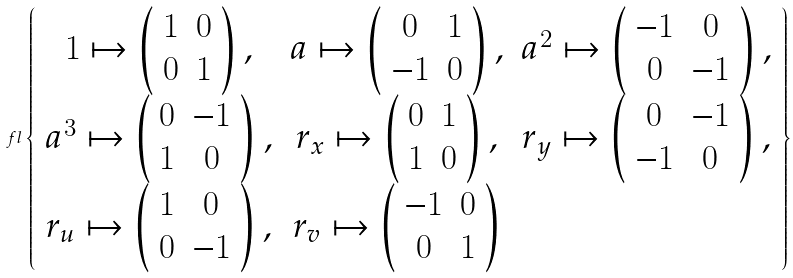<formula> <loc_0><loc_0><loc_500><loc_500>\ f l \left \{ \begin{array} { c c c c } 1 \mapsto \left ( \begin{array} { c c } 1 & 0 \\ 0 & 1 \end{array} \right ) , & a \mapsto \left ( \begin{array} { c c } 0 & 1 \\ - 1 & 0 \end{array} \right ) , & a ^ { 2 } \mapsto \left ( \begin{array} { c c } - 1 & 0 \\ 0 & - 1 \end{array} \right ) , \\ a ^ { 3 } \mapsto \left ( \begin{array} { c c } 0 & - 1 \\ 1 & 0 \end{array} \right ) , & r _ { x } \mapsto \left ( \begin{array} { c c } 0 & 1 \\ 1 & 0 \end{array} \right ) , & r _ { y } \mapsto \left ( \begin{array} { c c } 0 & - 1 \\ - 1 & 0 \end{array} \right ) , \\ r _ { u } \mapsto \left ( \begin{array} { c c } 1 & 0 \\ 0 & - 1 \end{array} \right ) , & r _ { v } \mapsto \left ( \begin{array} { c c } - 1 & 0 \\ 0 & 1 \end{array} \right ) \end{array} \right \}</formula> 